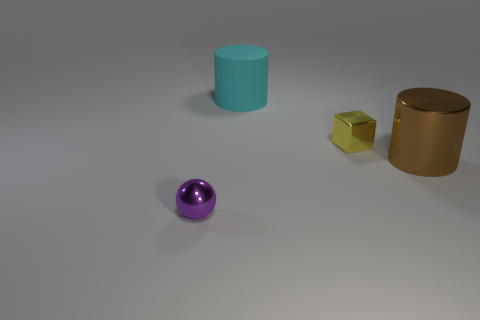Do the cylinder that is to the right of the big rubber cylinder and the large cyan object have the same material?
Give a very brief answer. No. How many things are brown metallic cylinders or small things that are on the left side of the cyan cylinder?
Keep it short and to the point. 2. There is a tiny block that is made of the same material as the tiny ball; what is its color?
Give a very brief answer. Yellow. What number of cyan cylinders are made of the same material as the yellow object?
Your response must be concise. 0. What number of matte cylinders are there?
Provide a short and direct response. 1. Is the color of the metallic object to the right of the tiny yellow metal object the same as the small thing that is behind the purple metallic object?
Offer a terse response. No. There is a big brown metallic cylinder; what number of objects are to the left of it?
Provide a succinct answer. 3. Are there any purple metal things that have the same shape as the small yellow metal thing?
Make the answer very short. No. Are the big cylinder that is left of the tiny yellow cube and the tiny object to the right of the purple object made of the same material?
Offer a very short reply. No. What size is the metal thing that is right of the small shiny thing to the right of the cyan rubber object left of the big brown shiny object?
Offer a terse response. Large. 